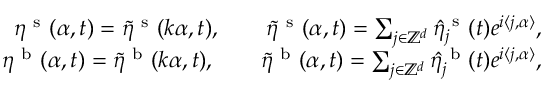<formula> <loc_0><loc_0><loc_500><loc_500>\begin{array} { r } { \eta ^ { s } ( \alpha , t ) = \tilde { \eta } ^ { s } ( \boldsymbol k \alpha , t ) , \quad \tilde { \eta } ^ { s } ( \boldsymbol \alpha , t ) = \sum _ { j \in \mathbb { Z } ^ { d } } \hat { \eta } _ { j } ^ { s } ( t ) e ^ { i \langle \boldsymbol j , \boldsymbol \alpha \rangle } , } \\ { \eta ^ { b } ( \alpha , t ) = \tilde { \eta } ^ { b } ( \boldsymbol k \alpha , t ) , \quad \tilde { \eta } ^ { b } ( \boldsymbol \alpha , t ) = \sum _ { j \in \mathbb { Z } ^ { d } } \hat { \eta } _ { j } ^ { b } ( t ) e ^ { i \langle \boldsymbol j , \boldsymbol \alpha \rangle } , } \end{array}</formula> 